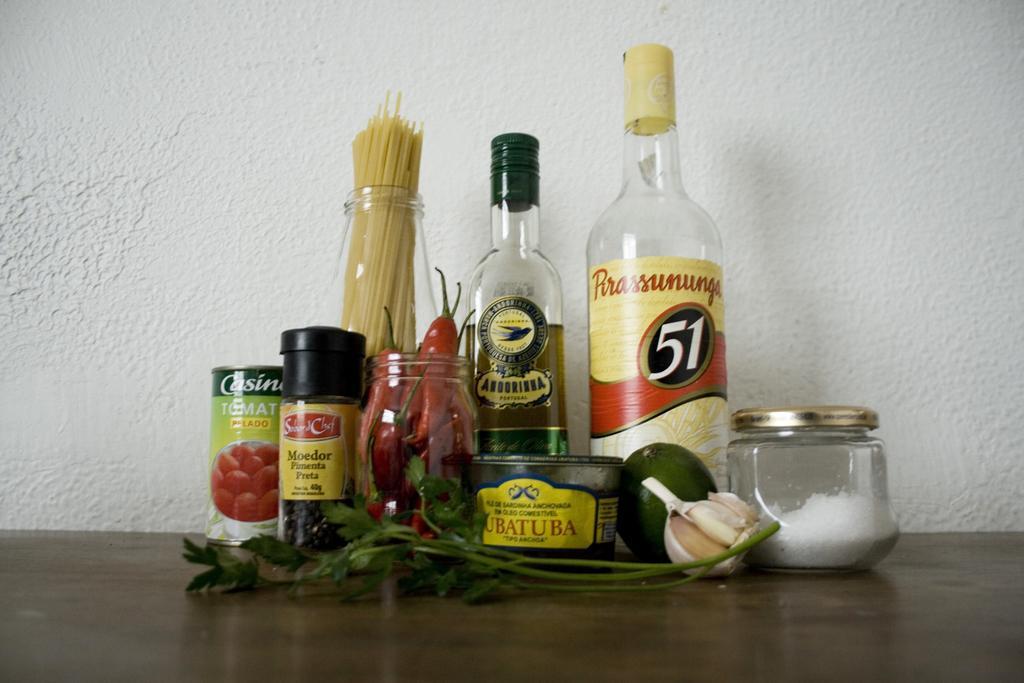Can you describe this image briefly? In this image I see 2 bottles, few jars and few other things over here. 